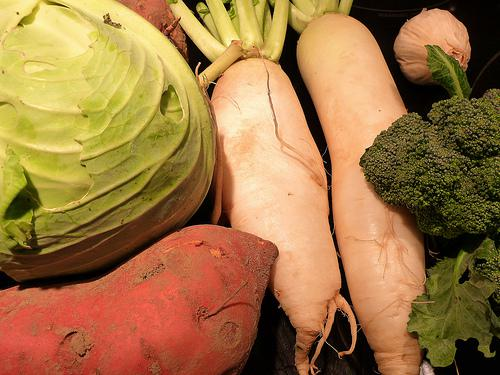Question: how many cabbages are there?
Choices:
A. Two.
B. None.
C. Several.
D. One.
Answer with the letter. Answer: D Question: what color is the table?
Choices:
A. Black.
B. Brown.
C. White.
D. Silver.
Answer with the letter. Answer: A 